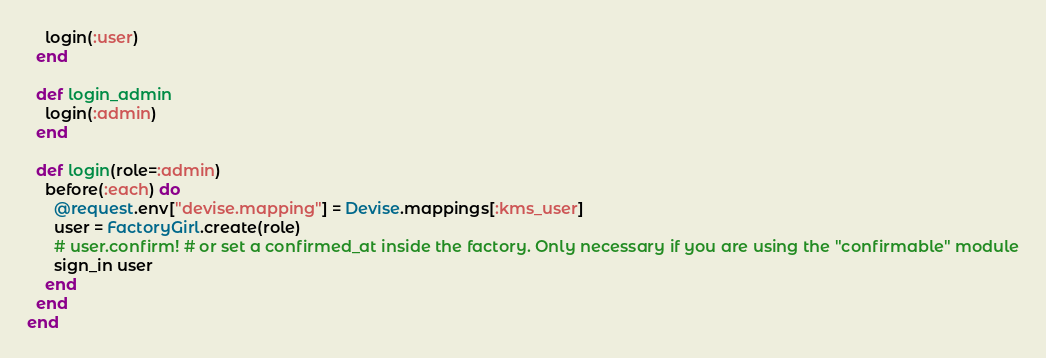Convert code to text. <code><loc_0><loc_0><loc_500><loc_500><_Ruby_>    login(:user)
  end

  def login_admin
    login(:admin)
  end

  def login(role=:admin)
    before(:each) do
      @request.env["devise.mapping"] = Devise.mappings[:kms_user]
      user = FactoryGirl.create(role)
      # user.confirm! # or set a confirmed_at inside the factory. Only necessary if you are using the "confirmable" module
      sign_in user
    end
  end
end
</code> 